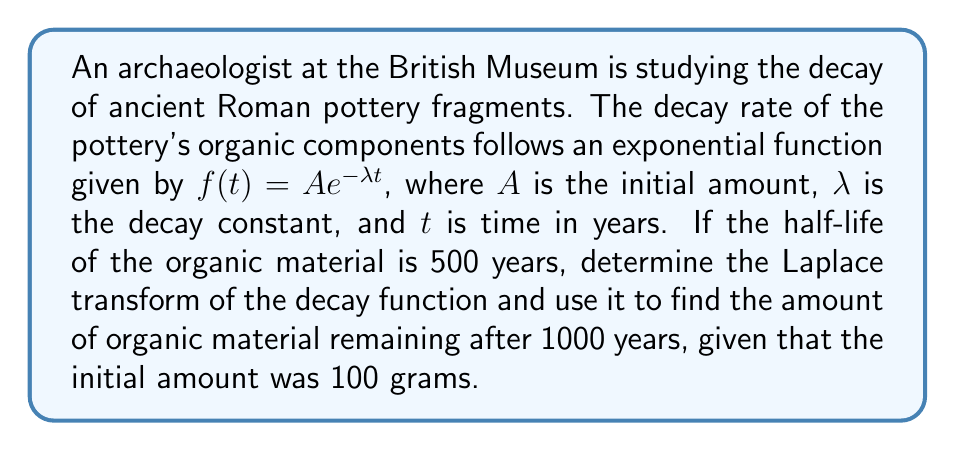Give your solution to this math problem. 1) First, we need to determine the decay constant $\lambda$ using the half-life:

   $T_{1/2} = \frac{\ln(2)}{\lambda}$
   $500 = \frac{\ln(2)}{\lambda}$
   $\lambda = \frac{\ln(2)}{500} \approx 0.001386$ per year

2) Now we can write our decay function:

   $f(t) = 100 e^{-0.001386t}$

3) The Laplace transform of $e^{at}$ is $\frac{1}{s-a}$, so the Laplace transform of our function is:

   $F(s) = \mathcal{L}\{f(t)\} = 100 \cdot \frac{1}{s+0.001386}$

4) To find the amount after 1000 years, we can use the original function:

   $f(1000) = 100 e^{-0.001386 \cdot 1000} \approx 25.0919$ grams

5) Alternatively, we could use the inverse Laplace transform:

   $f(t) = \mathcal{L}^{-1}\{F(s)\} = 100 e^{-0.001386t}$

   And then evaluate at $t=1000$.
Answer: $F(s) = \frac{100}{s+0.001386}$; 25.0919 grams 